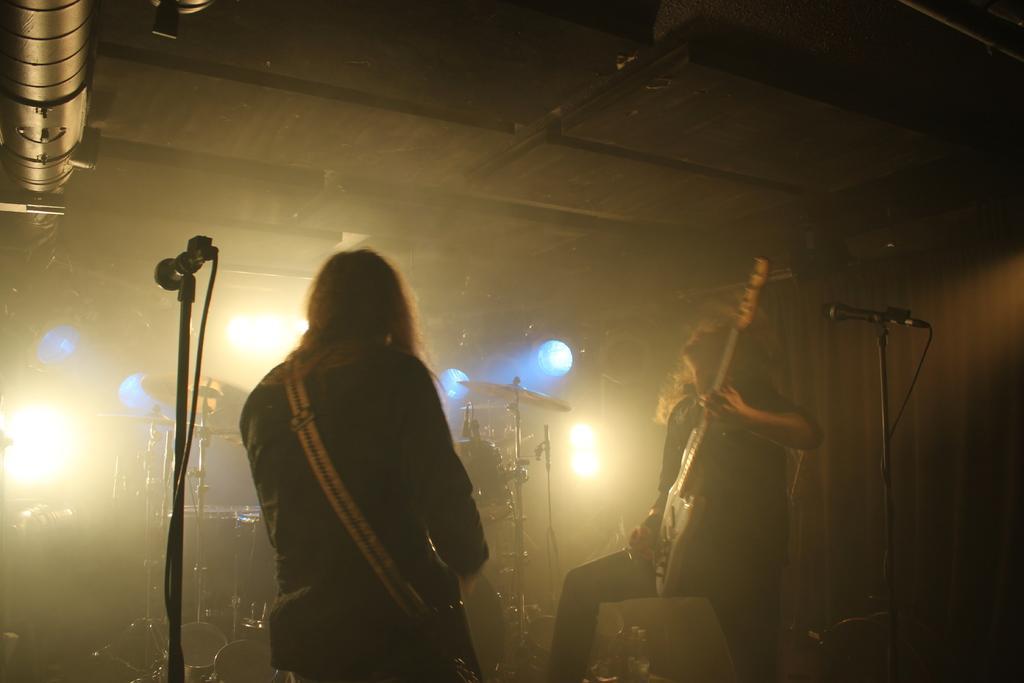Please provide a concise description of this image. In the picture we can see two men standing and playing guitar, we can see microphones and in the background of the picture there are some drums and lights. 